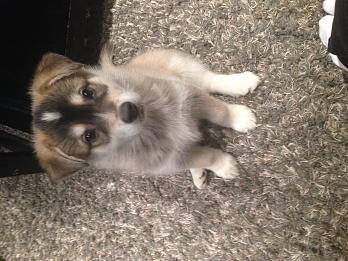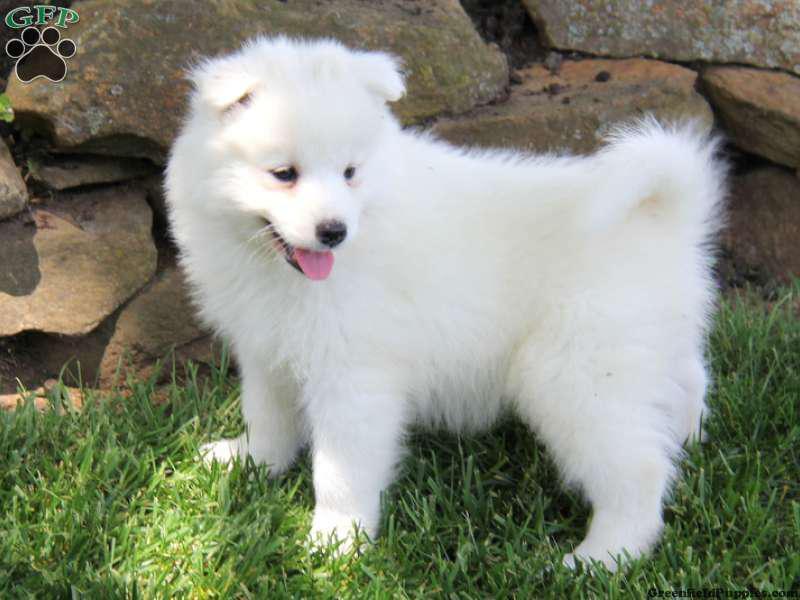The first image is the image on the left, the second image is the image on the right. Evaluate the accuracy of this statement regarding the images: "A dog is looking toward the right side.". Is it true? Answer yes or no. Yes. The first image is the image on the left, the second image is the image on the right. For the images displayed, is the sentence "One image shows exactly one white dog with its ears flopped forward, and the other image shows one dog with 'salt-and-pepper' fur coloring, and all dogs shown are young instead of full grown." factually correct? Answer yes or no. Yes. 